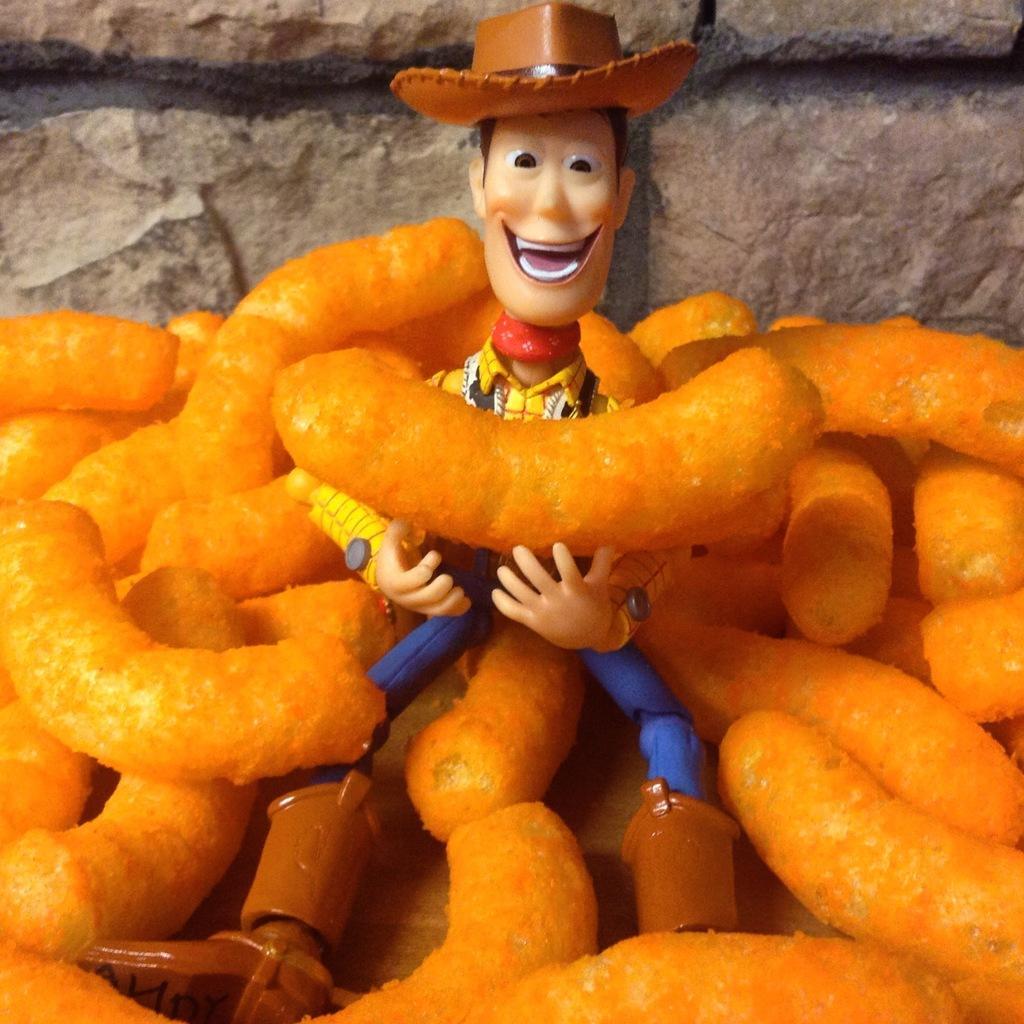Describe this image in one or two sentences. In this image we can see a toy and food item on an object. In the background of the image there is a wall. 